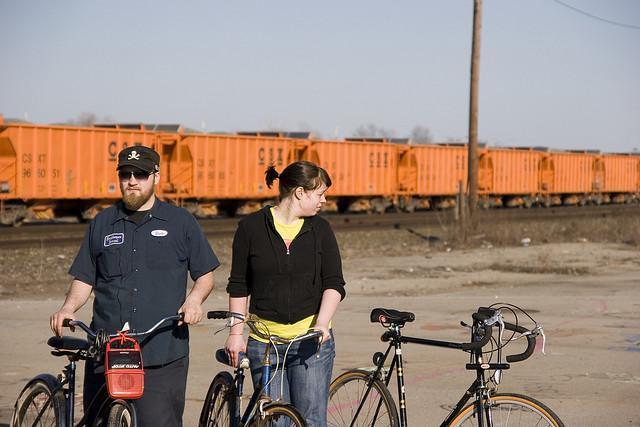How many bicycles are pictured?
Give a very brief answer. 3. How many bikes are there?
Give a very brief answer. 3. How many bicycles are there?
Give a very brief answer. 3. How many people are there?
Give a very brief answer. 2. How many bottles of water are on the table?
Give a very brief answer. 0. 